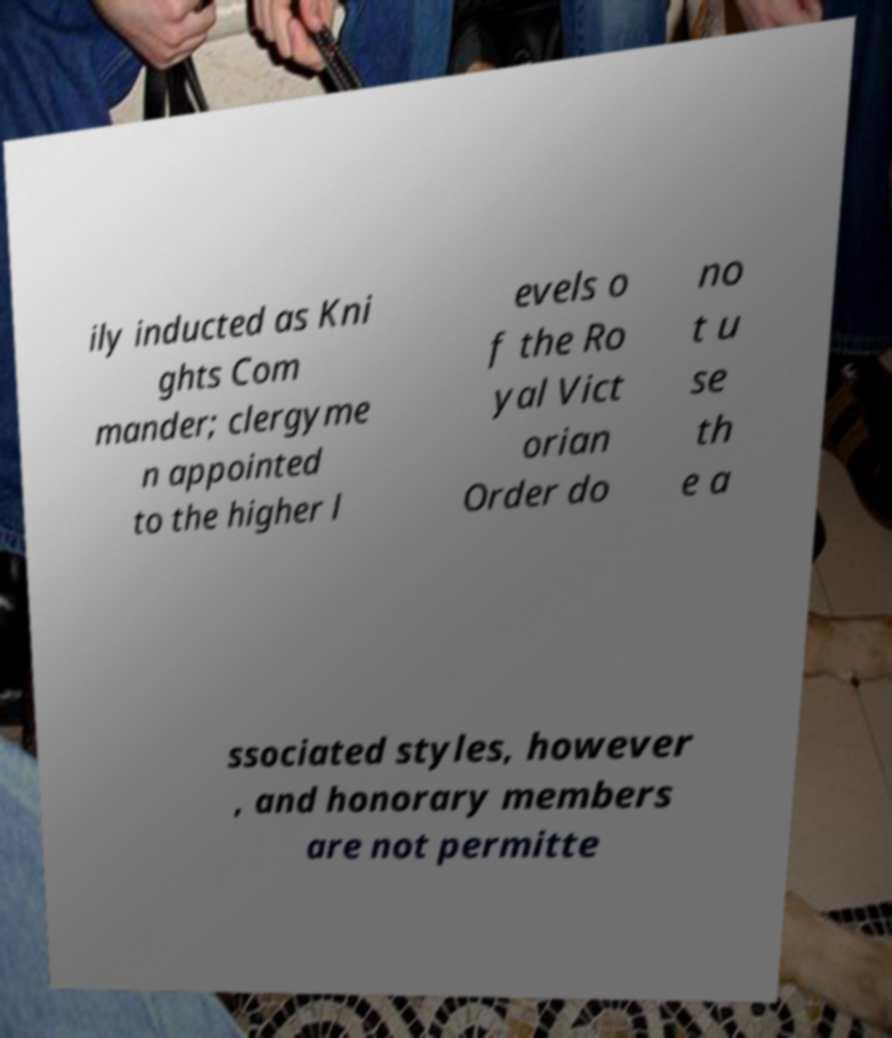Please read and relay the text visible in this image. What does it say? ily inducted as Kni ghts Com mander; clergyme n appointed to the higher l evels o f the Ro yal Vict orian Order do no t u se th e a ssociated styles, however , and honorary members are not permitte 